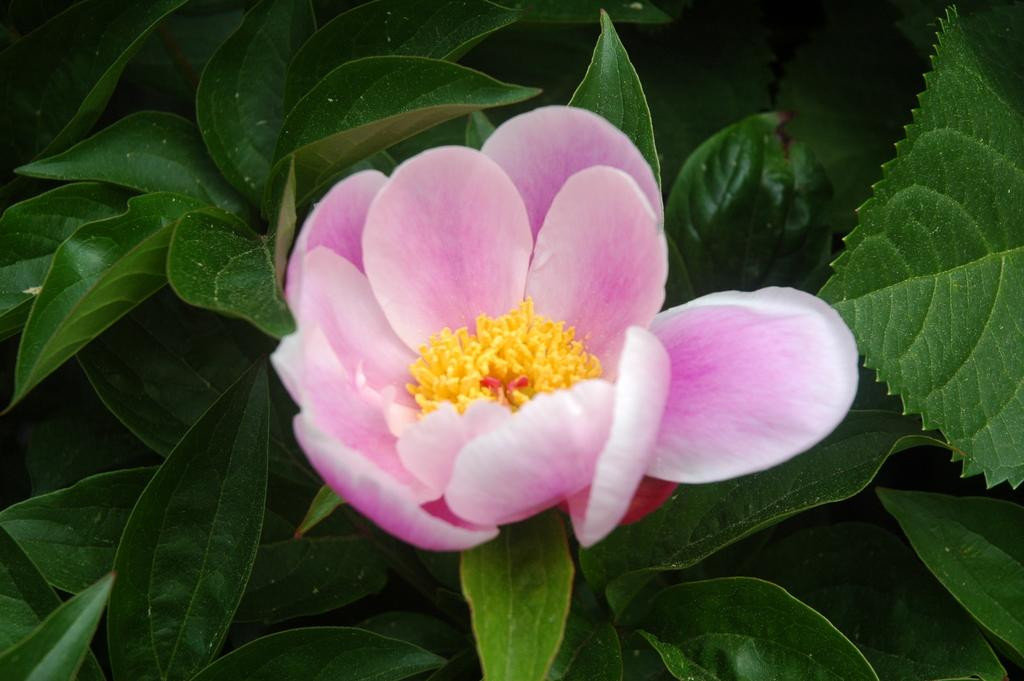What type of plant can be seen in the image? There is a flower in the image. What else is visible in the image besides the flower? There are leaves in the image. What route should the beginner take to find the answer in the image? There is no route or answer present in the image, as it only features a flower and leaves. 